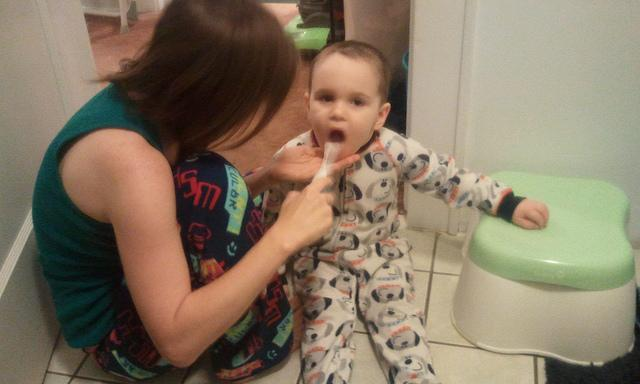What is the woman helping the child do?

Choices:
A) cut nails
B) brush teeth
C) comb hair
D) clean ears brush teeth 